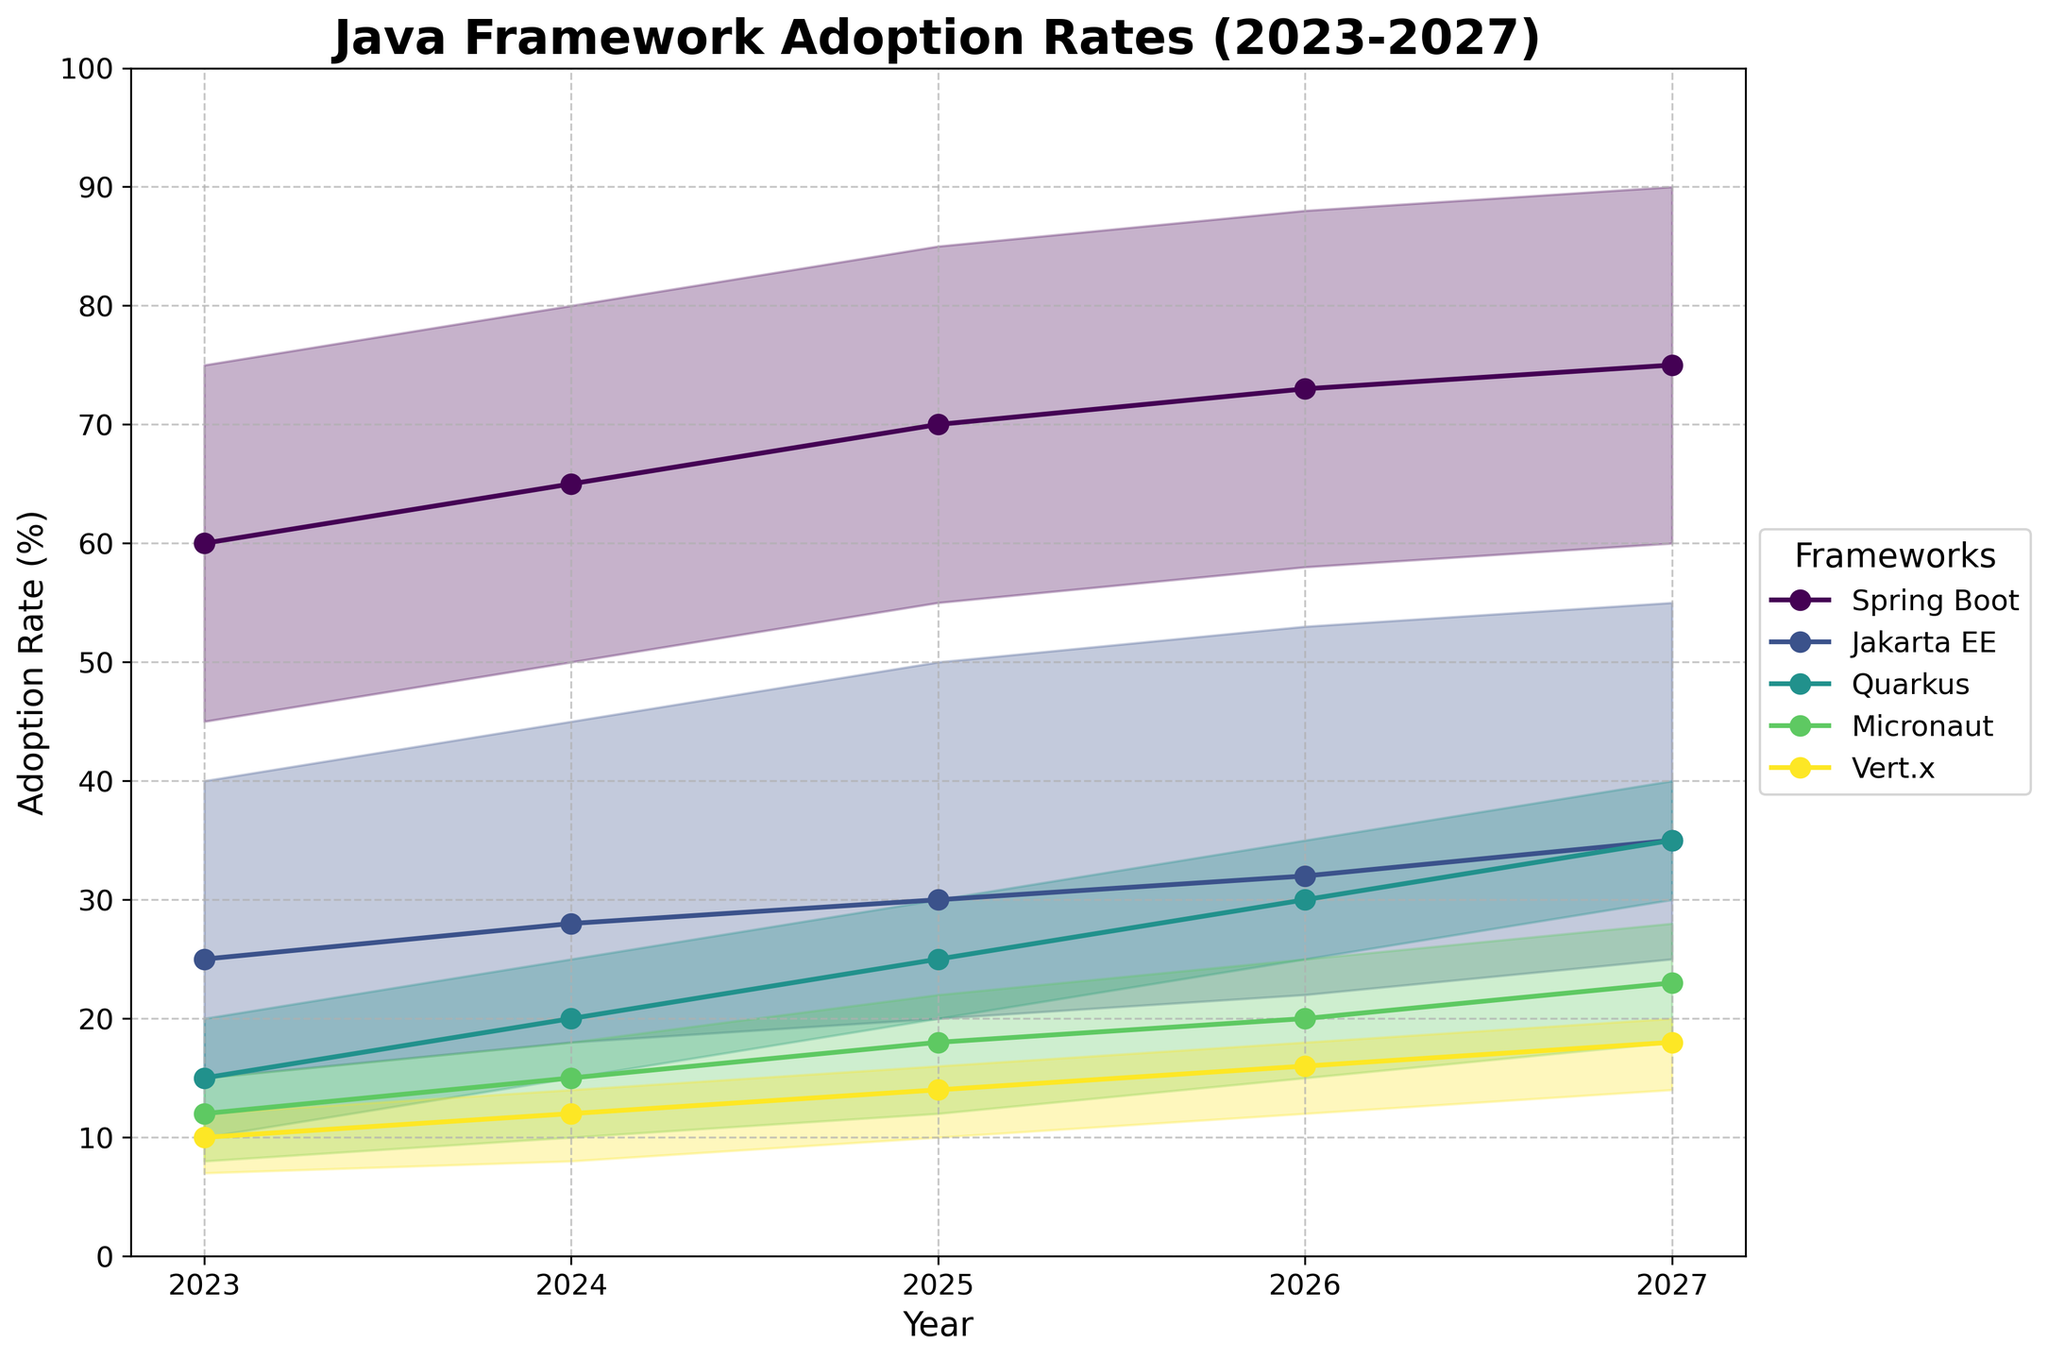What's the overall adoption trend of Spring Boot from 2023 to 2027? To determine the trend, observe the adoption rates of Spring Boot over the years 2023 to 2027. The values for small, medium, and large enterprises all increase each year, indicating a rising trend.
Answer: Increasing Which enterprise size has the highest adoption rate for Vert.x in 2027? Vert.x adoption rates in 2027 are 14% for small enterprises, 18% for medium enterprises, and 20% for large enterprises. The highest rate is for large enterprises.
Answer: Large enterprises What is the difference in Quarkus adoption rates between small and large enterprises in 2025? For 2025, small enterprises have a 20% adoption rate and large enterprises have 30%. The difference is obtained by subtracting 20 from 30.
Answer: 10% Which framework shows the largest increase in adoption rate for small enterprises from 2023 to 2027? Calculate the increases for each framework by subtracting the 2023 values from the 2027 values: Spring Boot (60-45=15), Jakarta EE (25-15=10), Quarkus (30-10=20), Micronaut (18-8=10), Vert.x (14-7=7). Quarkus has the largest increase.
Answer: Quarkus What is the average adoption rate of Jakarta EE for medium enterprises over the 5 years? Sum the adoption rates for medium enterprises from 2023 to 2027: 25+28+30+32+35 = 150. Divide by the number of years (5).
Answer: 30% Compare the adoption rates of Micronaut and Vert.x for large enterprises in 2026. Which one is higher? In 2026, Micronaut has an adoption rate of 25% and Vert.x has 18%. Micronaut's rate is higher.
Answer: Micronaut What is the range of Spring Boot’s adoption rate for medium enterprises from 2023 to 2027? Find the minimum (60% in 2023) and maximum (75% in 2027) adoption rates, then subtract the minimum from the maximum: 75 - 60 = 15.
Answer: 15% By how much does the adoption rate of Jakarta EE increase for large enterprises from 2023 to 2024? The adoption rate for large enterprises grows from 40% in 2023 to 45% in 2024. Subtract 40 from 45.
Answer: 5% What's the expected rate of Micronaut adoption among small enterprises in 2026? Look at the data for small enterprises in 2026 where Micronaut has an adoption rate of 15%.
Answer: 15% 